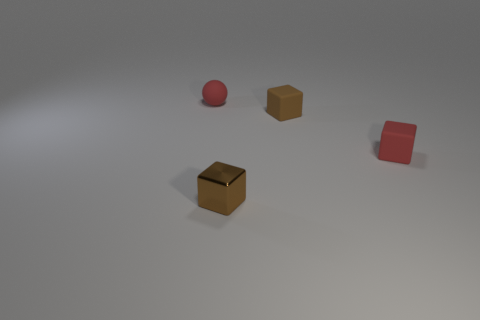What size is the red ball that is made of the same material as the small red block?
Offer a terse response. Small. What number of tiny red rubber objects have the same shape as the small brown metallic object?
Offer a terse response. 1. There is a red object that is the same size as the red block; what is it made of?
Your response must be concise. Rubber. Are there any big purple balls that have the same material as the red block?
Provide a short and direct response. No. What is the color of the small thing that is both on the left side of the brown rubber object and behind the small red block?
Ensure brevity in your answer.  Red. How many other objects are there of the same color as the metallic object?
Your response must be concise. 1. There is a ball that is behind the red matte object that is in front of the rubber thing to the left of the brown rubber block; what is its material?
Ensure brevity in your answer.  Rubber. What number of spheres are tiny red objects or matte objects?
Your answer should be very brief. 1. Are there any other things that have the same size as the red matte block?
Your response must be concise. Yes. There is a red rubber thing right of the thing that is on the left side of the metal block; how many red objects are to the left of it?
Offer a terse response. 1. 